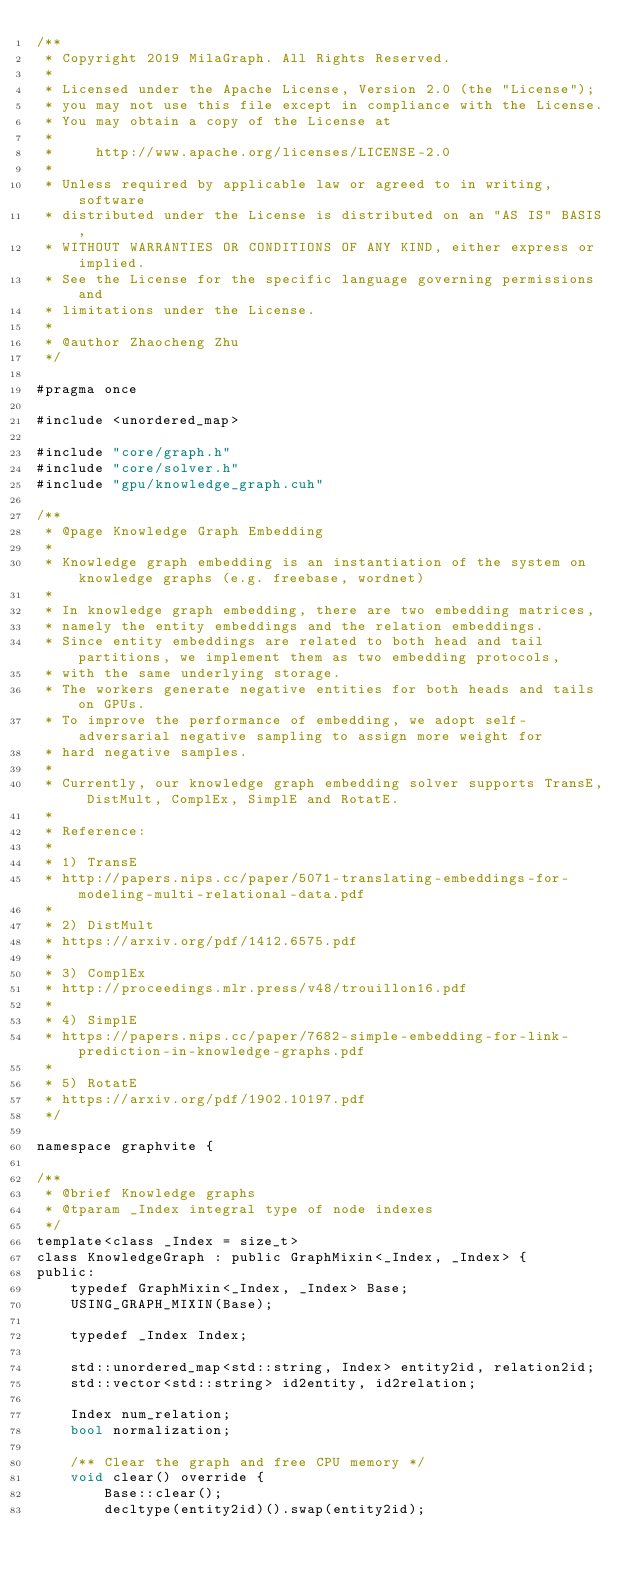Convert code to text. <code><loc_0><loc_0><loc_500><loc_500><_Cuda_>/**
 * Copyright 2019 MilaGraph. All Rights Reserved.
 *
 * Licensed under the Apache License, Version 2.0 (the "License");
 * you may not use this file except in compliance with the License.
 * You may obtain a copy of the License at
 *
 *     http://www.apache.org/licenses/LICENSE-2.0
 *
 * Unless required by applicable law or agreed to in writing, software
 * distributed under the License is distributed on an "AS IS" BASIS,
 * WITHOUT WARRANTIES OR CONDITIONS OF ANY KIND, either express or implied.
 * See the License for the specific language governing permissions and
 * limitations under the License.
 *
 * @author Zhaocheng Zhu
 */

#pragma once

#include <unordered_map>

#include "core/graph.h"
#include "core/solver.h"
#include "gpu/knowledge_graph.cuh"

/**
 * @page Knowledge Graph Embedding
 *
 * Knowledge graph embedding is an instantiation of the system on knowledge graphs (e.g. freebase, wordnet)
 *
 * In knowledge graph embedding, there are two embedding matrices,
 * namely the entity embeddings and the relation embeddings.
 * Since entity embeddings are related to both head and tail partitions, we implement them as two embedding protocols,
 * with the same underlying storage.
 * The workers generate negative entities for both heads and tails on GPUs.
 * To improve the performance of embedding, we adopt self-adversarial negative sampling to assign more weight for
 * hard negative samples.
 *
 * Currently, our knowledge graph embedding solver supports TransE, DistMult, ComplEx, SimplE and RotatE.
 *
 * Reference:
 *
 * 1) TransE
 * http://papers.nips.cc/paper/5071-translating-embeddings-for-modeling-multi-relational-data.pdf
 *
 * 2) DistMult
 * https://arxiv.org/pdf/1412.6575.pdf
 *
 * 3) ComplEx
 * http://proceedings.mlr.press/v48/trouillon16.pdf
 *
 * 4) SimplE
 * https://papers.nips.cc/paper/7682-simple-embedding-for-link-prediction-in-knowledge-graphs.pdf
 *
 * 5) RotatE
 * https://arxiv.org/pdf/1902.10197.pdf
 */

namespace graphvite {

/**
 * @brief Knowledge graphs
 * @tparam _Index integral type of node indexes
 */
template<class _Index = size_t>
class KnowledgeGraph : public GraphMixin<_Index, _Index> {
public:
    typedef GraphMixin<_Index, _Index> Base;
    USING_GRAPH_MIXIN(Base);

    typedef _Index Index;

    std::unordered_map<std::string, Index> entity2id, relation2id;
    std::vector<std::string> id2entity, id2relation;

    Index num_relation;
    bool normalization;

    /** Clear the graph and free CPU memory */
    void clear() override {
        Base::clear();
        decltype(entity2id)().swap(entity2id);</code> 